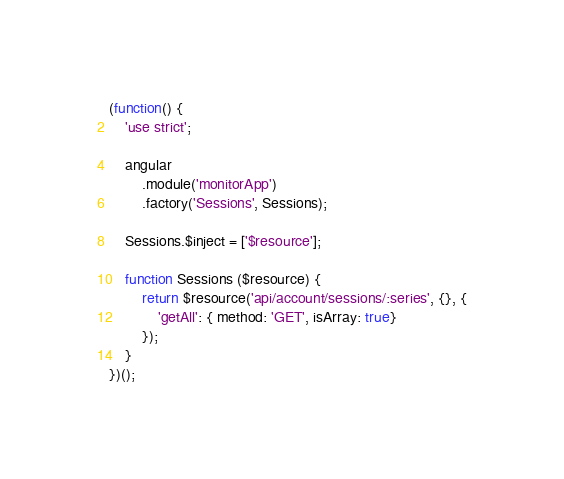Convert code to text. <code><loc_0><loc_0><loc_500><loc_500><_JavaScript_>(function() {
    'use strict';

    angular
        .module('monitorApp')
        .factory('Sessions', Sessions);

    Sessions.$inject = ['$resource'];

    function Sessions ($resource) {
        return $resource('api/account/sessions/:series', {}, {
            'getAll': { method: 'GET', isArray: true}
        });
    }
})();
</code> 